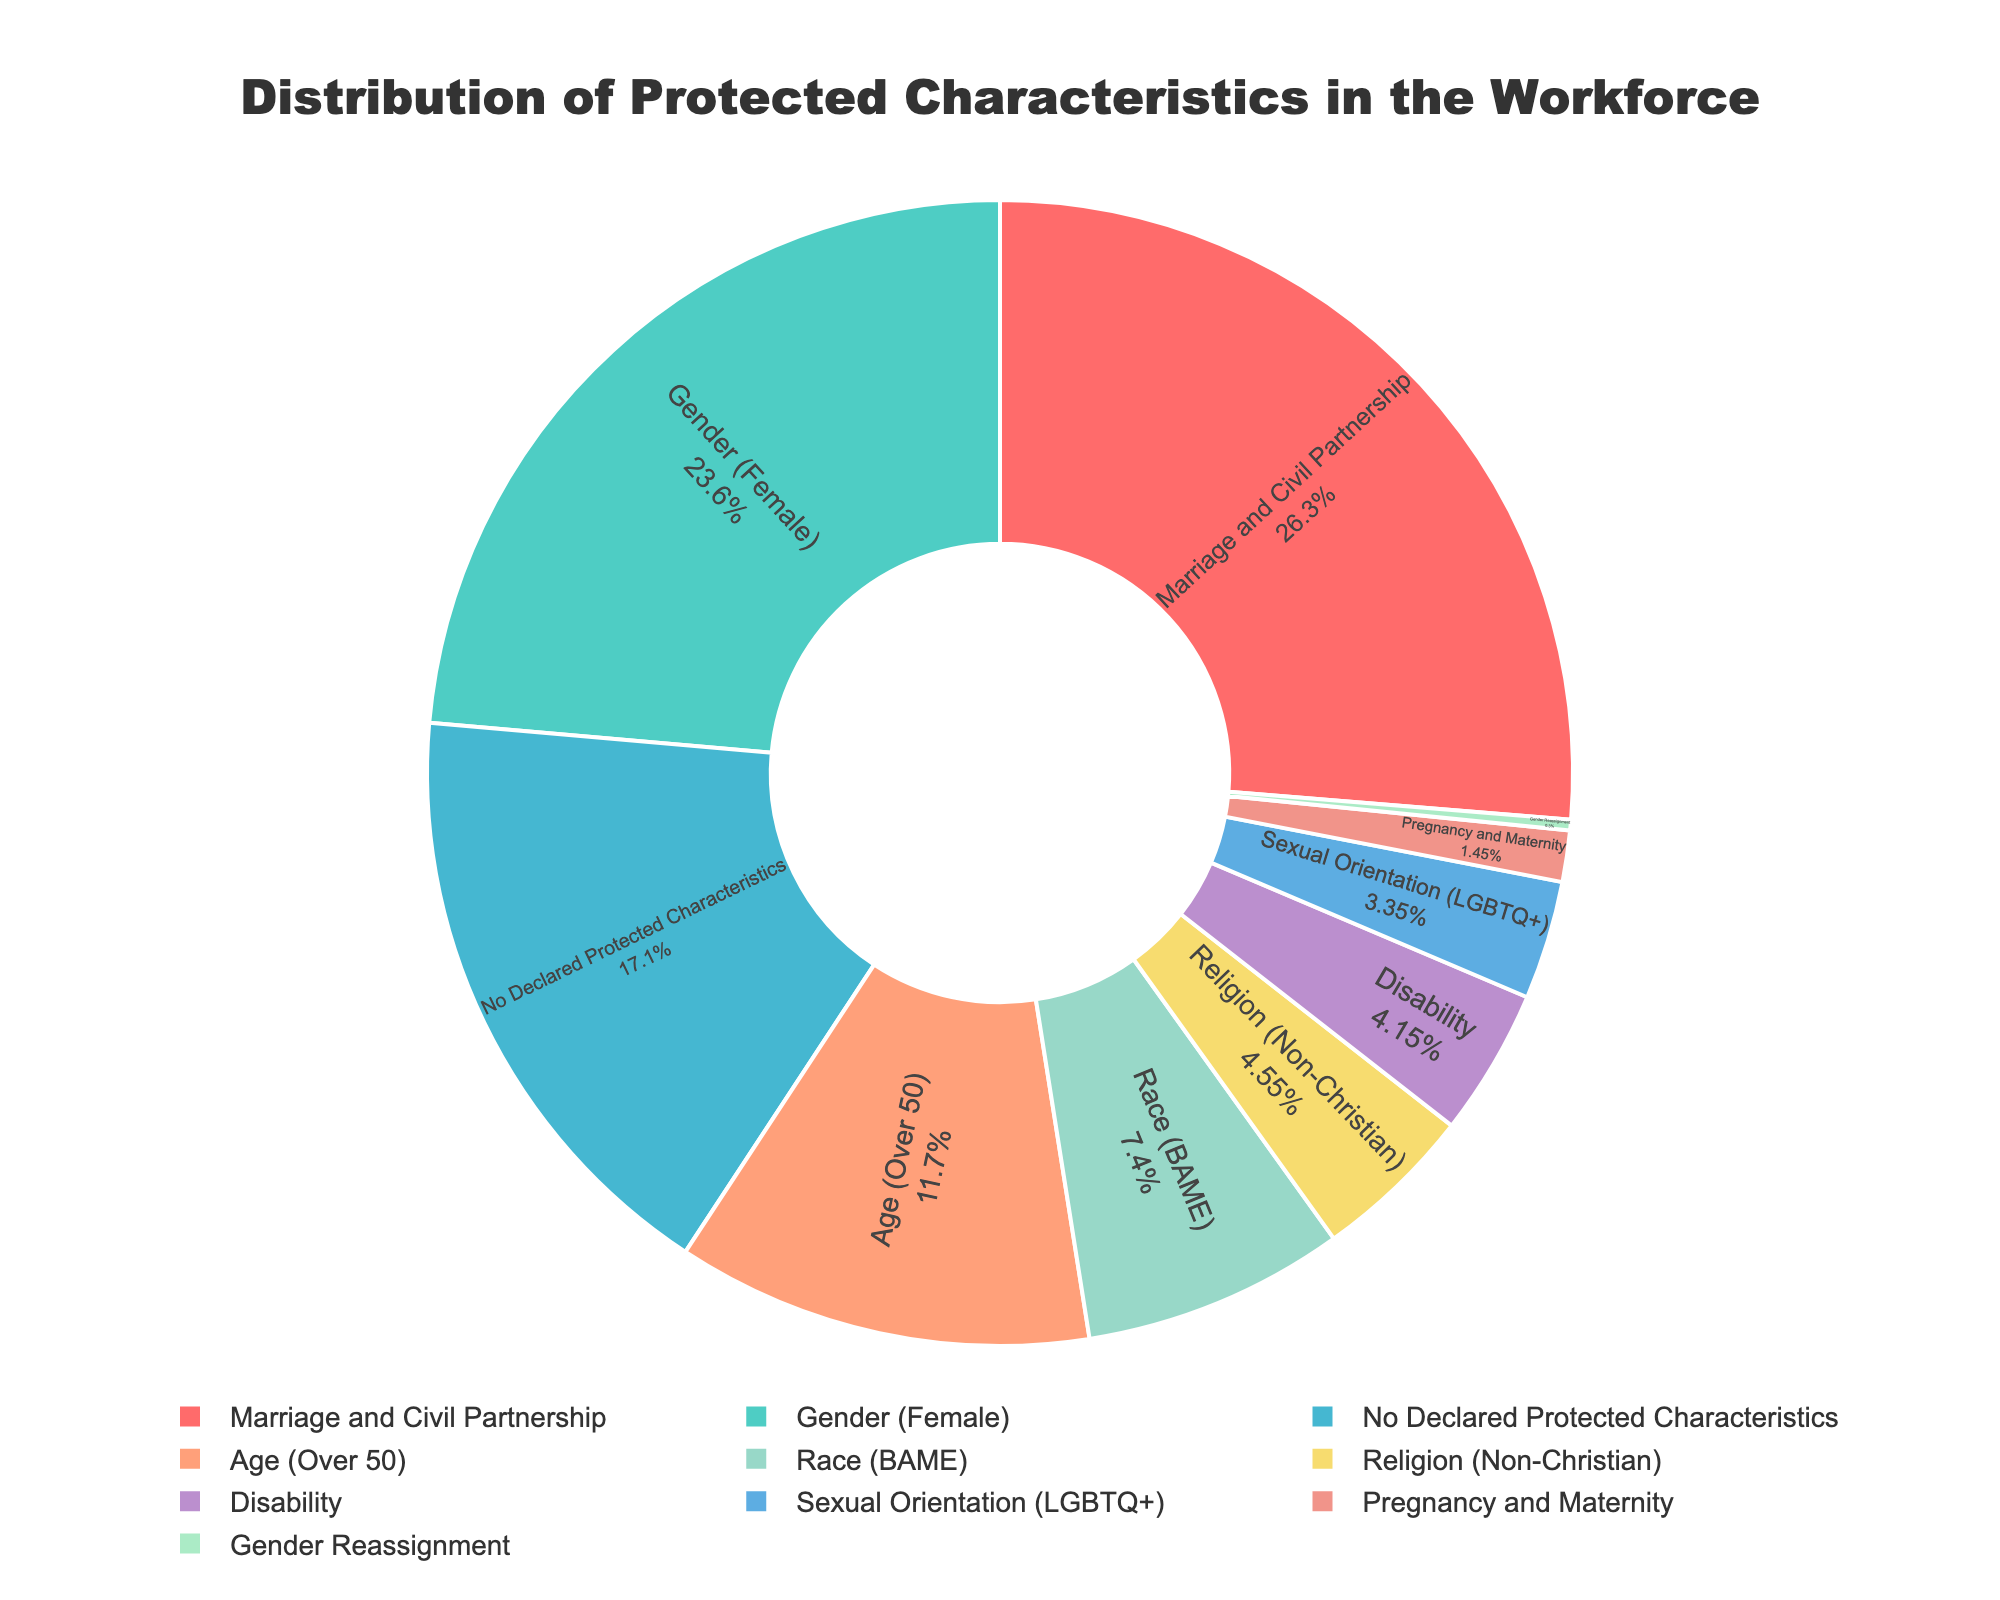Which protected characteristic has the highest percentage? Look at the pie chart and identify the segment with the largest part of the circle.
Answer: Marriage and Civil Partnership Which two protected characteristics together account for more than half of the workforce? Combine the percentages of the top characteristics until you reach over 50%. The top two are Marriage and Civil Partnership (52.6%) and Gender (Female) (47.2%).
Answer: Marriage and Civil Partnership, Gender (Female) What is the difference in percentage between Age (Over 50) and Race (BAME)? Subtract the percentage of Race (BAME) from Age (Over 50): 23.5% - 14.8% = 8.7%
Answer: 8.7% Which protected characteristic has the smallest percentage? Find the segment with the smallest part of the circle.
Answer: Gender Reassignment What is the total percentage of workforce members with declared protected characteristics? Subtract the percentage of "No Declared Protected Characteristics" from 100%: 100% - 34.3% = 65.7%
Answer: 65.7% Between Disability and Religion (Non-Christian), which has the higher percentage? Compare the segments for Disability (8.3%) and Religion (Non-Christian) (9.1%).
Answer: Religion (Non-Christian) How does the percentage of LGBTQ+ compare to that of Pregnancy and Maternity? Compare the segments for LGBTQ+ (6.7%) and Pregnancy and Maternity (2.9%).
Answer: LGBTQ+ is higher Which characteristic has a similar percentage to Religion (Non-Christian)? Find the closest percentage value to Religion (Non-Christian) (9.1%).
Answer: Age (Over 50) with 23.5% and Race (BAME) with 14.8% If one were to combine the percentages of Disability and Sexual Orientation (LGBTQ+), what would be the total? Add the percentages of Disability (8.3%) and Sexual Orientation (LGBTQ+) (6.7%): 8.3% + 6.7% = 15%
Answer: 15% What color represents the Religion (Non-Christian) segment? Identify the color correlated with the "Religion (Non-Christian)" label in the chart.
Answer: Yellow 